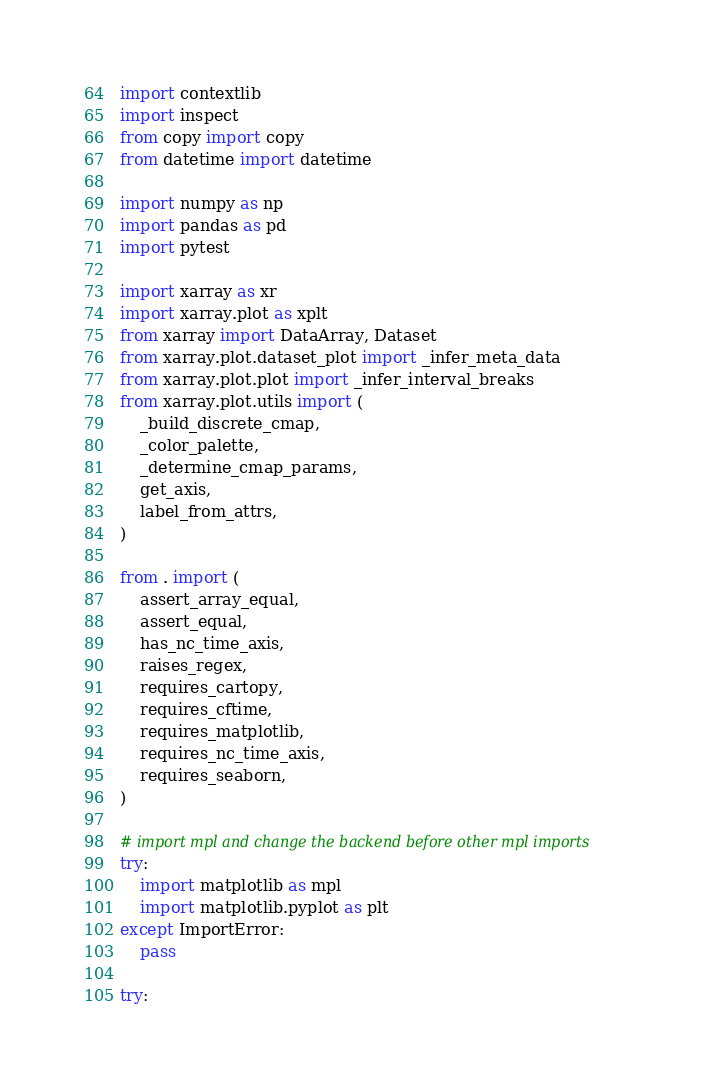Convert code to text. <code><loc_0><loc_0><loc_500><loc_500><_Python_>import contextlib
import inspect
from copy import copy
from datetime import datetime

import numpy as np
import pandas as pd
import pytest

import xarray as xr
import xarray.plot as xplt
from xarray import DataArray, Dataset
from xarray.plot.dataset_plot import _infer_meta_data
from xarray.plot.plot import _infer_interval_breaks
from xarray.plot.utils import (
    _build_discrete_cmap,
    _color_palette,
    _determine_cmap_params,
    get_axis,
    label_from_attrs,
)

from . import (
    assert_array_equal,
    assert_equal,
    has_nc_time_axis,
    raises_regex,
    requires_cartopy,
    requires_cftime,
    requires_matplotlib,
    requires_nc_time_axis,
    requires_seaborn,
)

# import mpl and change the backend before other mpl imports
try:
    import matplotlib as mpl
    import matplotlib.pyplot as plt
except ImportError:
    pass

try:</code> 